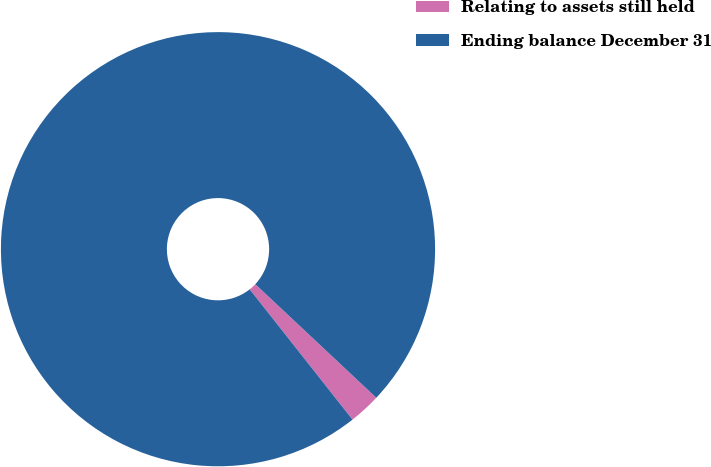<chart> <loc_0><loc_0><loc_500><loc_500><pie_chart><fcel>Relating to assets still held<fcel>Ending balance December 31<nl><fcel>2.37%<fcel>97.63%<nl></chart> 